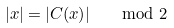Convert formula to latex. <formula><loc_0><loc_0><loc_500><loc_500>| x | & = | C ( x ) | \quad \mod 2</formula> 